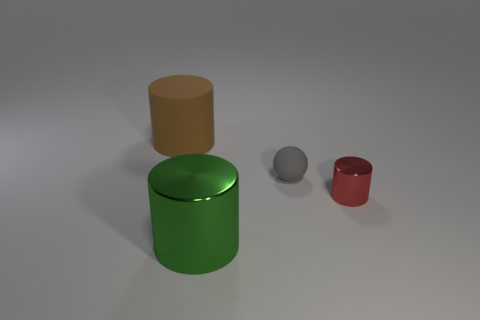Add 4 green metal cylinders. How many objects exist? 8 Subtract all balls. How many objects are left? 3 Add 3 metallic objects. How many metallic objects are left? 5 Add 4 tiny red cylinders. How many tiny red cylinders exist? 5 Subtract 0 gray cylinders. How many objects are left? 4 Subtract all gray balls. Subtract all big green things. How many objects are left? 2 